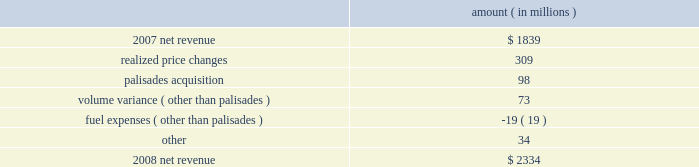Entergy corporation and subsidiaries management's financial discussion and analysis the purchased power capacity variance is primarily due to higher capacity charges .
A portion of the variance is due to the amortization of deferred capacity costs and is offset in base revenues due to base rate increases implemented to recover incremental deferred and ongoing purchased power capacity charges .
The volume/weather variance is primarily due to the effect of less favorable weather compared to the same period in 2007 and decreased electricity usage primarily during the unbilled sales period .
Hurricane gustav and hurricane ike , which hit the utility's service territories in september 2008 , contributed an estimated $ 46 million to the decrease in electricity usage .
Industrial sales were also depressed by the continuing effects of the hurricanes and , especially in the latter part of the year , because of the overall decline of the economy , leading to lower usage in the latter part of the year affecting both the large customer industrial segment as well as small and mid-sized industrial customers .
The decreases in electricity usage were partially offset by an increase in residential and commercial customer electricity usage that occurred during the periods of the year not affected by the hurricanes .
The retail electric price variance is primarily due to : an increase in the attala power plant costs recovered through the power management rider by entergy mississippi .
The net income effect of this recovery is limited to a portion representing an allowed return on equity with the remainder offset by attala power plant costs in other operation and maintenance expenses , depreciation expenses , and taxes other than income taxes ; a storm damage rider that became effective in october 2007 at entergy mississippi ; and an energy efficiency rider that became effective in november 2007 at entergy arkansas .
The establishment of the storm damage rider and the energy efficiency rider results in an increase in rider revenue and a corresponding increase in other operation and maintenance expense with no impact on net income .
The retail electric price variance was partially offset by : the absence of interim storm recoveries through the formula rate plans at entergy louisiana and entergy gulf states louisiana which ceased upon the act 55 financing of storm costs in the third quarter 2008 ; and a credit passed on to customers as a result of the act 55 storm cost financings .
Refer to "liquidity and capital resources - hurricane katrina and hurricane rita" below and note 2 to the financial statements for a discussion of the interim recovery of storm costs and the act 55 storm cost financings .
Non-utility nuclear following is an analysis of the change in net revenue comparing 2008 to 2007 .
Amount ( in millions ) .
As shown in the table above , net revenue for non-utility nuclear increased by $ 495 million , or 27% ( 27 % ) , in 2008 compared to 2007 primarily due to higher pricing in its contracts to sell power , additional production available from the acquisition of palisades in april 2007 , and fewer outage days .
In addition to the refueling outages shown in the .
What portion of the increase in net revenue from non-utility nuclear is attributed to the palisades acquisition? 
Computations: (98 / 495)
Answer: 0.19798. 